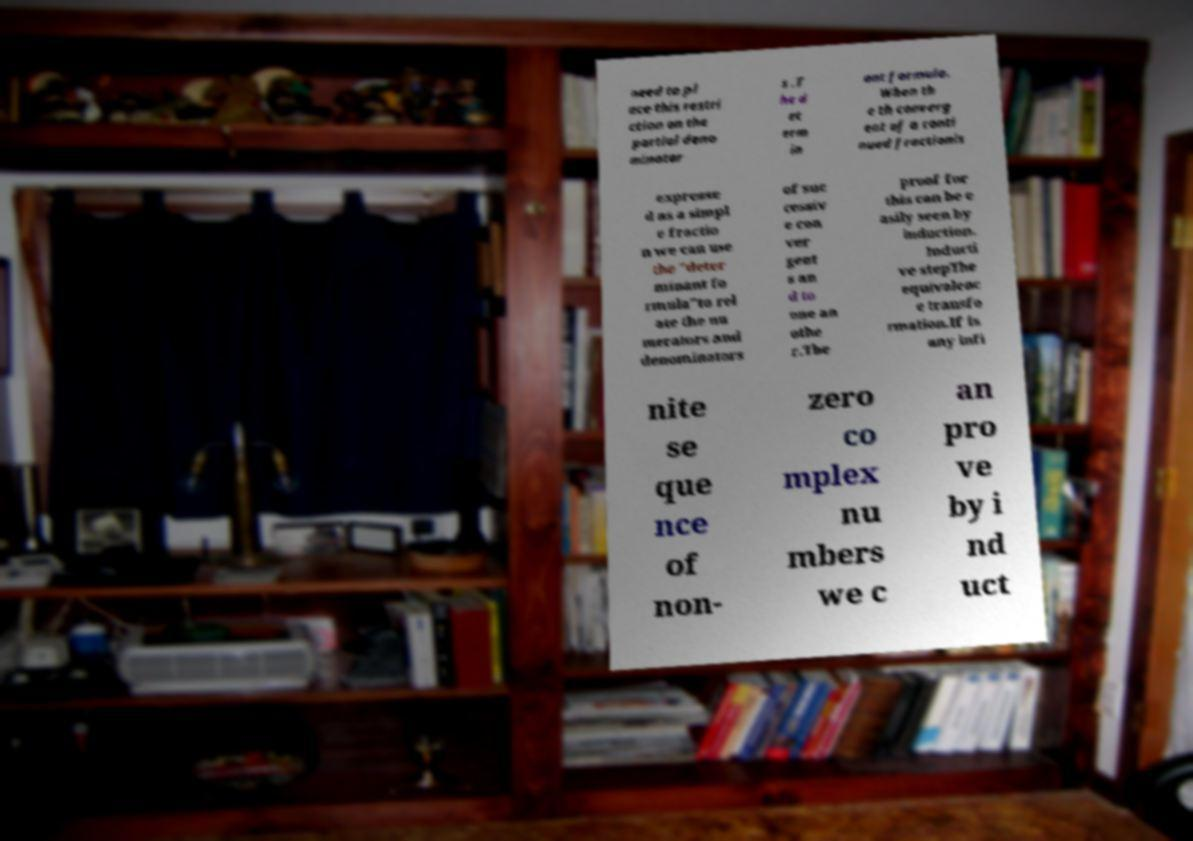Could you assist in decoding the text presented in this image and type it out clearly? need to pl ace this restri ction on the partial deno minator s .T he d et erm in ant formula. When th e th converg ent of a conti nued fractionis expresse d as a simpl e fractio n we can use the "deter minant fo rmula"to rel ate the nu merators and denominators of suc cessiv e con ver gent s an d to one an othe r.The proof for this can be e asily seen by induction. Inducti ve stepThe equivalenc e transfo rmation.If is any infi nite se que nce of non- zero co mplex nu mbers we c an pro ve by i nd uct 